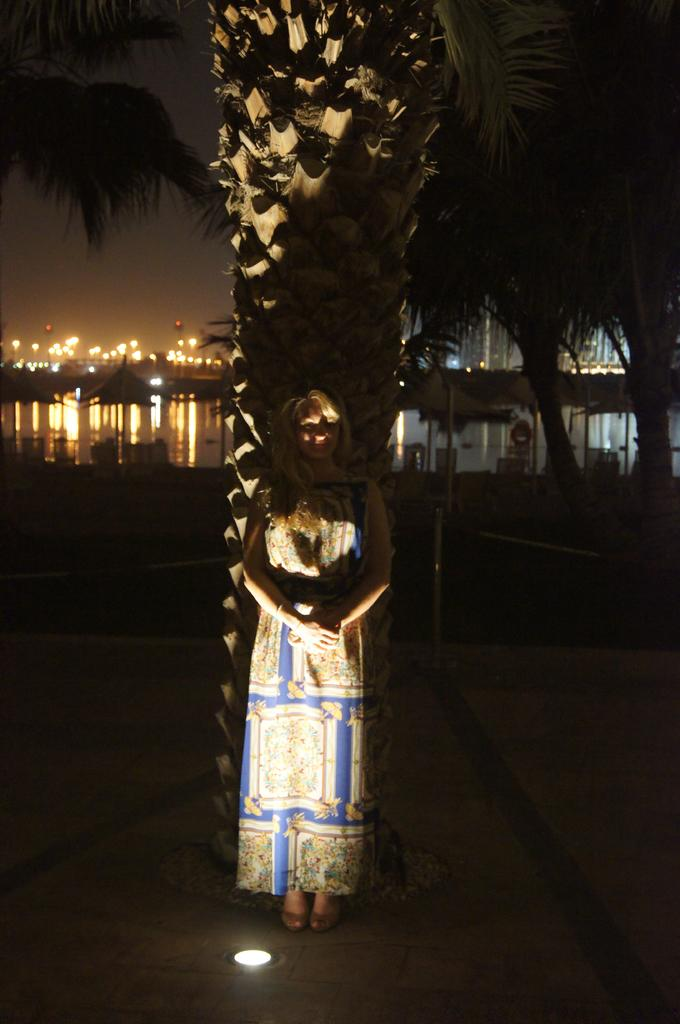What is the primary subject of the image? There is a woman standing in the image. What is the woman standing on? The woman is standing on the floor. What type of natural elements can be seen in the image? There are trees and water visible in the image. What type of artificial structures can be seen in the image? There is a building in the image. What type of lighting is present in the image? There are lights in the image. What additional objects are present in the image? There is an umbrella and some other objects in the image. What can be seen in the background of the image? The sky is visible in the background of the image. Where is the cave located in the image? There is no cave present in the image. What type of stocking is the woman wearing in the image? The provided facts do not mention any stockings, so it cannot be determined what type of stocking the woman is wearing. 